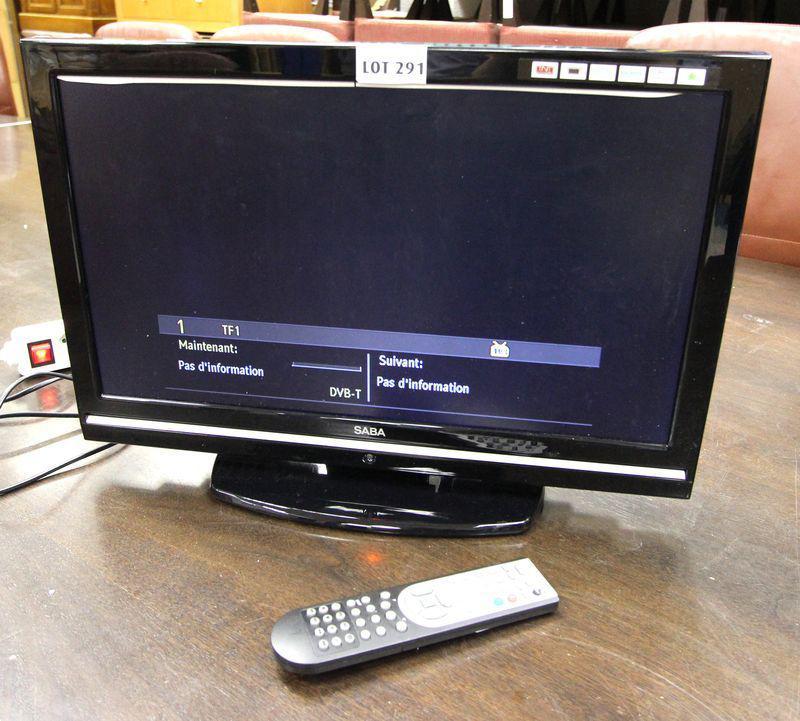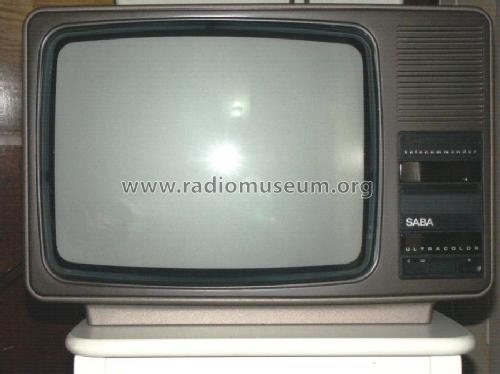The first image is the image on the left, the second image is the image on the right. For the images shown, is this caption "The left image has a remote next to a monitor on a wooden surface" true? Answer yes or no. Yes. The first image is the image on the left, the second image is the image on the right. Considering the images on both sides, is "the left pic is of a flat screen monitor" valid? Answer yes or no. Yes. 